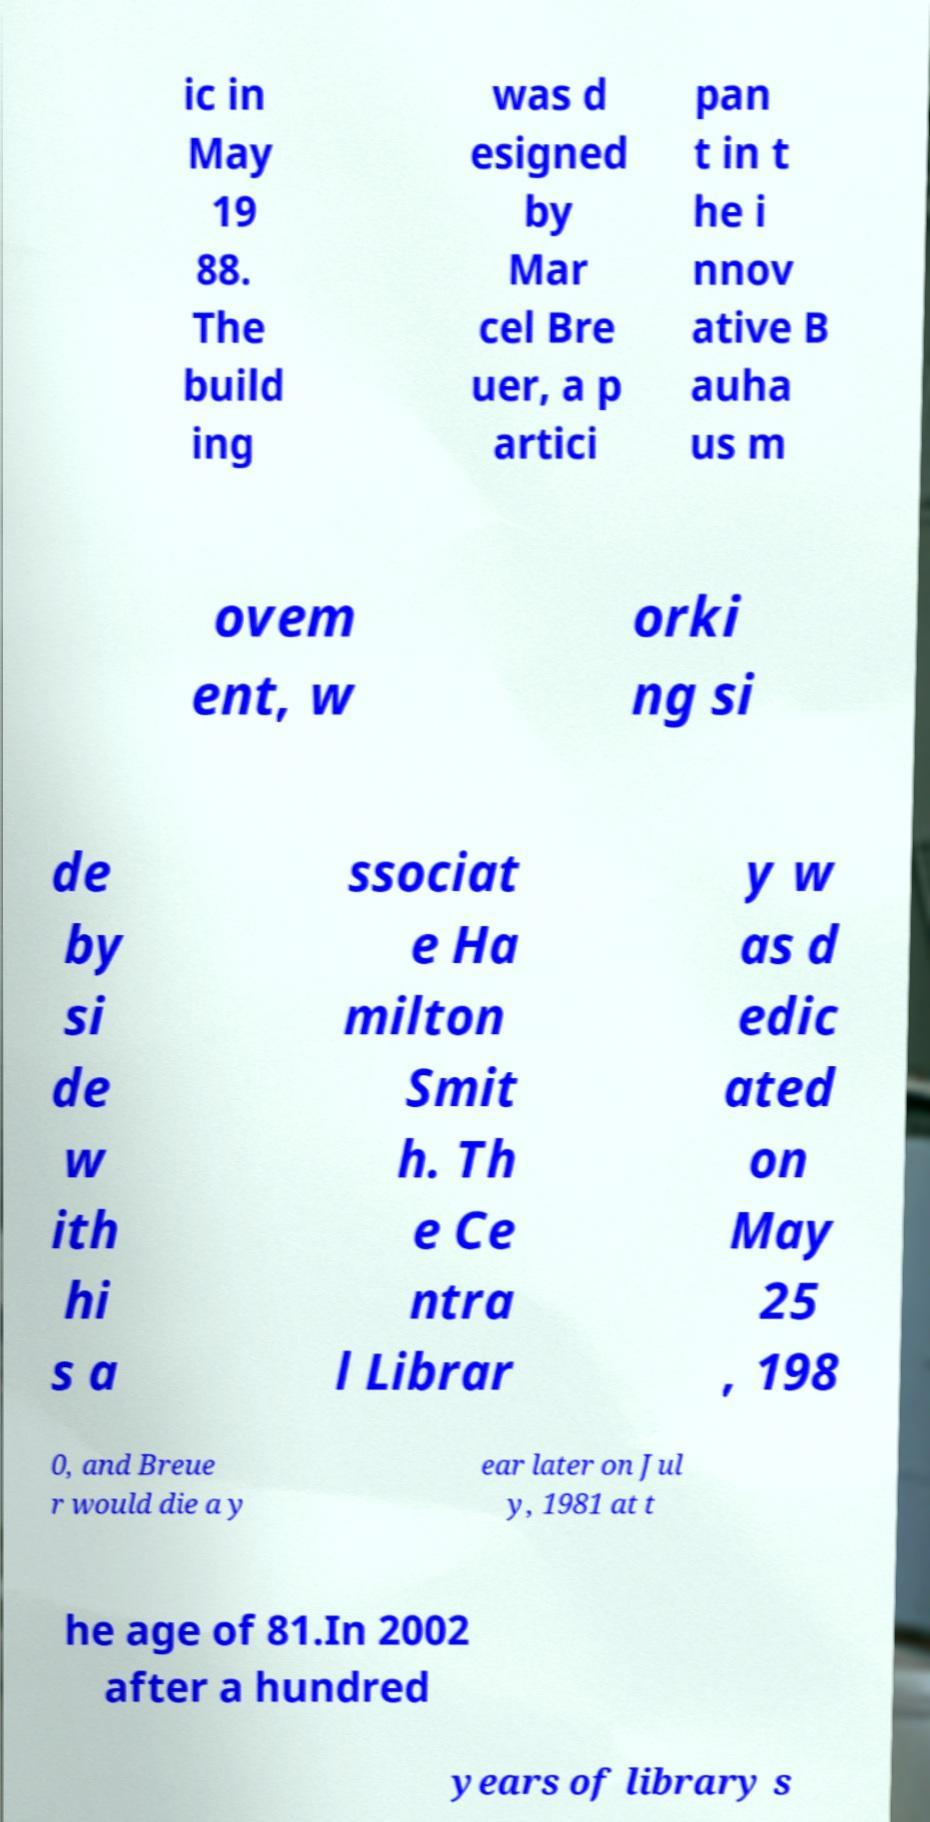Could you extract and type out the text from this image? ic in May 19 88. The build ing was d esigned by Mar cel Bre uer, a p artici pan t in t he i nnov ative B auha us m ovem ent, w orki ng si de by si de w ith hi s a ssociat e Ha milton Smit h. Th e Ce ntra l Librar y w as d edic ated on May 25 , 198 0, and Breue r would die a y ear later on Jul y, 1981 at t he age of 81.In 2002 after a hundred years of library s 